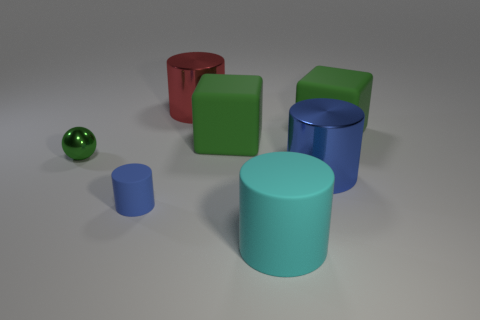What number of other things are the same color as the metal ball?
Your answer should be very brief. 2. What shape is the large cyan rubber object?
Keep it short and to the point. Cylinder. There is a metal cylinder in front of the metallic cylinder behind the metallic sphere; what color is it?
Ensure brevity in your answer.  Blue. Does the small matte cylinder have the same color as the big metal cylinder that is in front of the ball?
Your response must be concise. Yes. There is a green thing that is on the left side of the cyan rubber object and right of the tiny blue matte object; what is its material?
Make the answer very short. Rubber. Is there a gray metallic cylinder that has the same size as the green metallic ball?
Offer a very short reply. No. There is a cyan thing that is the same size as the red cylinder; what is its material?
Provide a succinct answer. Rubber. What number of big green rubber cubes are in front of the red thing?
Make the answer very short. 2. Do the tiny thing that is behind the tiny matte object and the large blue shiny object have the same shape?
Your response must be concise. No. Are there any tiny cyan shiny objects that have the same shape as the big blue metal object?
Offer a very short reply. No. 